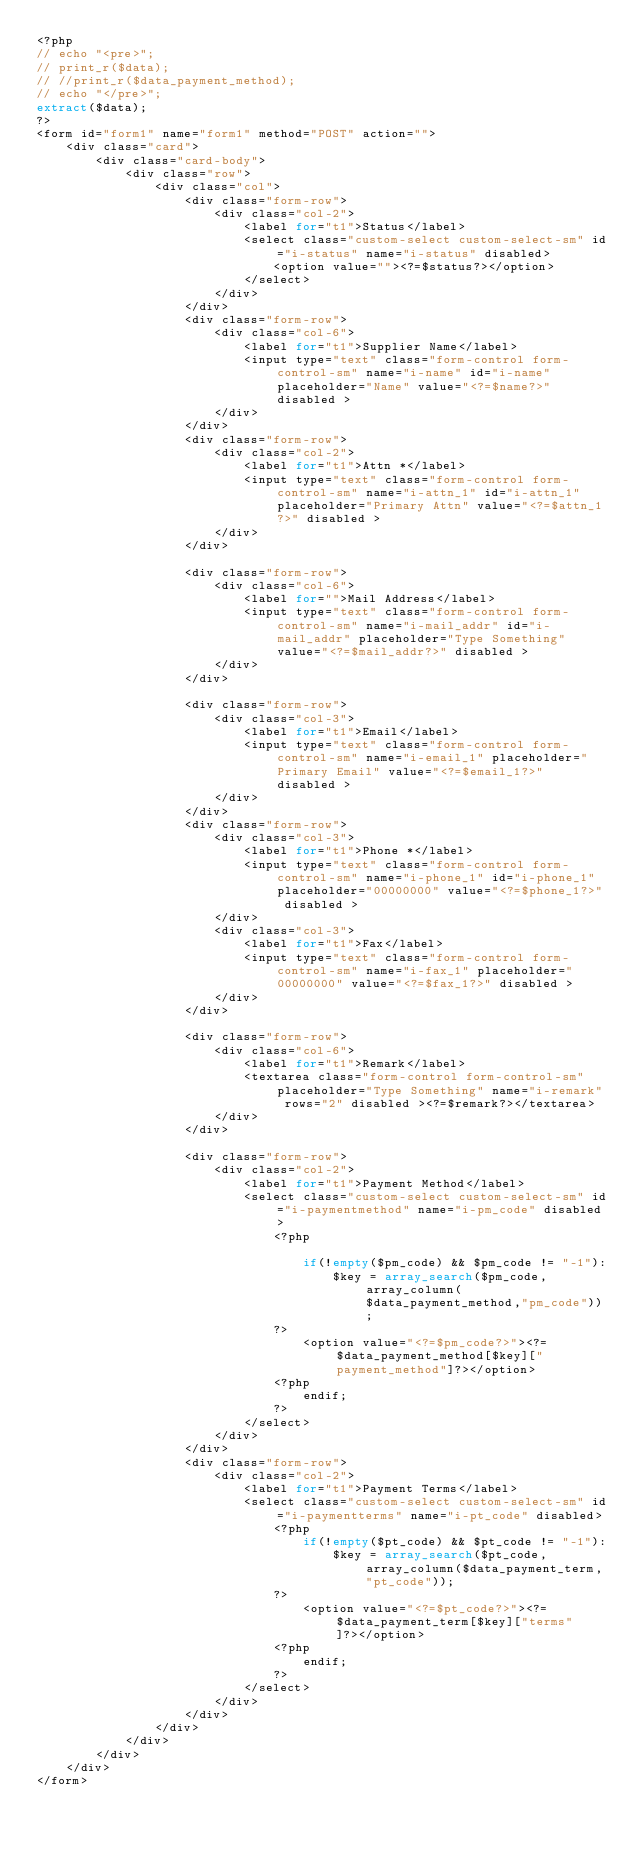<code> <loc_0><loc_0><loc_500><loc_500><_PHP_><?php
// echo "<pre>";
// print_r($data);
// //print_r($data_payment_method);
// echo "</pre>";
extract($data);
?>
<form id="form1" name="form1" method="POST" action="">
    <div class="card">
        <div class="card-body">
            <div class="row">
                <div class="col">
                    <div class="form-row">
                        <div class="col-2">
                            <label for="t1">Status</label>
                            <select class="custom-select custom-select-sm" id="i-status" name="i-status" disabled>
                                <option value=""><?=$status?></option>
                            </select>
                        </div>
                    </div>
                    <div class="form-row">
                        <div class="col-6">
                            <label for="t1">Supplier Name</label>
                            <input type="text" class="form-control form-control-sm" name="i-name" id="i-name" placeholder="Name" value="<?=$name?>" disabled >
                        </div>
                    </div>
                    <div class="form-row">
                        <div class="col-2">
                            <label for="t1">Attn *</label>
                            <input type="text" class="form-control form-control-sm" name="i-attn_1" id="i-attn_1" placeholder="Primary Attn" value="<?=$attn_1?>" disabled >
                        </div>
                    </div>

                    <div class="form-row">
                        <div class="col-6">
                            <label for="">Mail Address</label>
                            <input type="text" class="form-control form-control-sm" name="i-mail_addr" id="i-mail_addr" placeholder="Type Something" value="<?=$mail_addr?>" disabled >
                        </div>
                    </div>

                    <div class="form-row">
                        <div class="col-3">
                            <label for="t1">Email</label>
                            <input type="text" class="form-control form-control-sm" name="i-email_1" placeholder="Primary Email" value="<?=$email_1?>" disabled >
                        </div>
                    </div>
                    <div class="form-row">
                        <div class="col-3">
                            <label for="t1">Phone *</label>
                            <input type="text" class="form-control form-control-sm" name="i-phone_1" id="i-phone_1" placeholder="00000000" value="<?=$phone_1?>" disabled >
                        </div>
                        <div class="col-3">
                            <label for="t1">Fax</label>
                            <input type="text" class="form-control form-control-sm" name="i-fax_1" placeholder="00000000" value="<?=$fax_1?>" disabled >
                        </div>
                    </div>

                    <div class="form-row">
                        <div class="col-6">
                            <label for="t1">Remark</label>
                            <textarea class="form-control form-control-sm" placeholder="Type Something" name="i-remark" rows="2" disabled ><?=$remark?></textarea>
                        </div>
                    </div>

                    <div class="form-row">
                        <div class="col-2">
                            <label for="t1">Payment Method</label>
                            <select class="custom-select custom-select-sm" id="i-paymentmethod" name="i-pm_code" disabled>
                                <?php 
                                    
                                    if(!empty($pm_code) && $pm_code != "-1"):
                                        $key = array_search($pm_code, array_column($data_payment_method,"pm_code"));	
                                ?>
                                    <option value="<?=$pm_code?>"><?=$data_payment_method[$key]["payment_method"]?></option>
                                <?php
                                    endif;
                                ?>
                            </select>
                        </div>
                    </div>
                    <div class="form-row">
                        <div class="col-2">
                            <label for="t1">Payment Terms</label>
                            <select class="custom-select custom-select-sm" id="i-paymentterms" name="i-pt_code" disabled>
                                <?php 
                                    if(!empty($pt_code) && $pt_code != "-1"):
                                        $key = array_search($pt_code, array_column($data_payment_term,"pt_code"));
                                ?>
                                    <option value="<?=$pt_code?>"><?=$data_payment_term[$key]["terms"]?></option>
                                <?php
                                    endif;
                                ?>    
                            </select>
                        </div>
                    </div>
                </div>
            </div>
        </div>
    </div>
</form></code> 